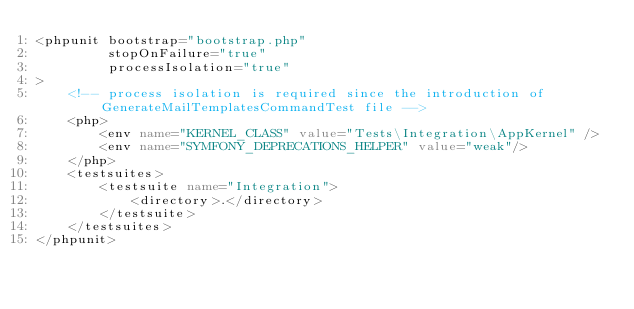<code> <loc_0><loc_0><loc_500><loc_500><_XML_><phpunit bootstrap="bootstrap.php"
         stopOnFailure="true"
         processIsolation="true"
>
    <!-- process isolation is required since the introduction of GenerateMailTemplatesCommandTest file -->
    <php>
        <env name="KERNEL_CLASS" value="Tests\Integration\AppKernel" />
        <env name="SYMFONY_DEPRECATIONS_HELPER" value="weak"/>
    </php>
    <testsuites>
        <testsuite name="Integration">
            <directory>.</directory>
        </testsuite>
    </testsuites>
</phpunit>
</code> 